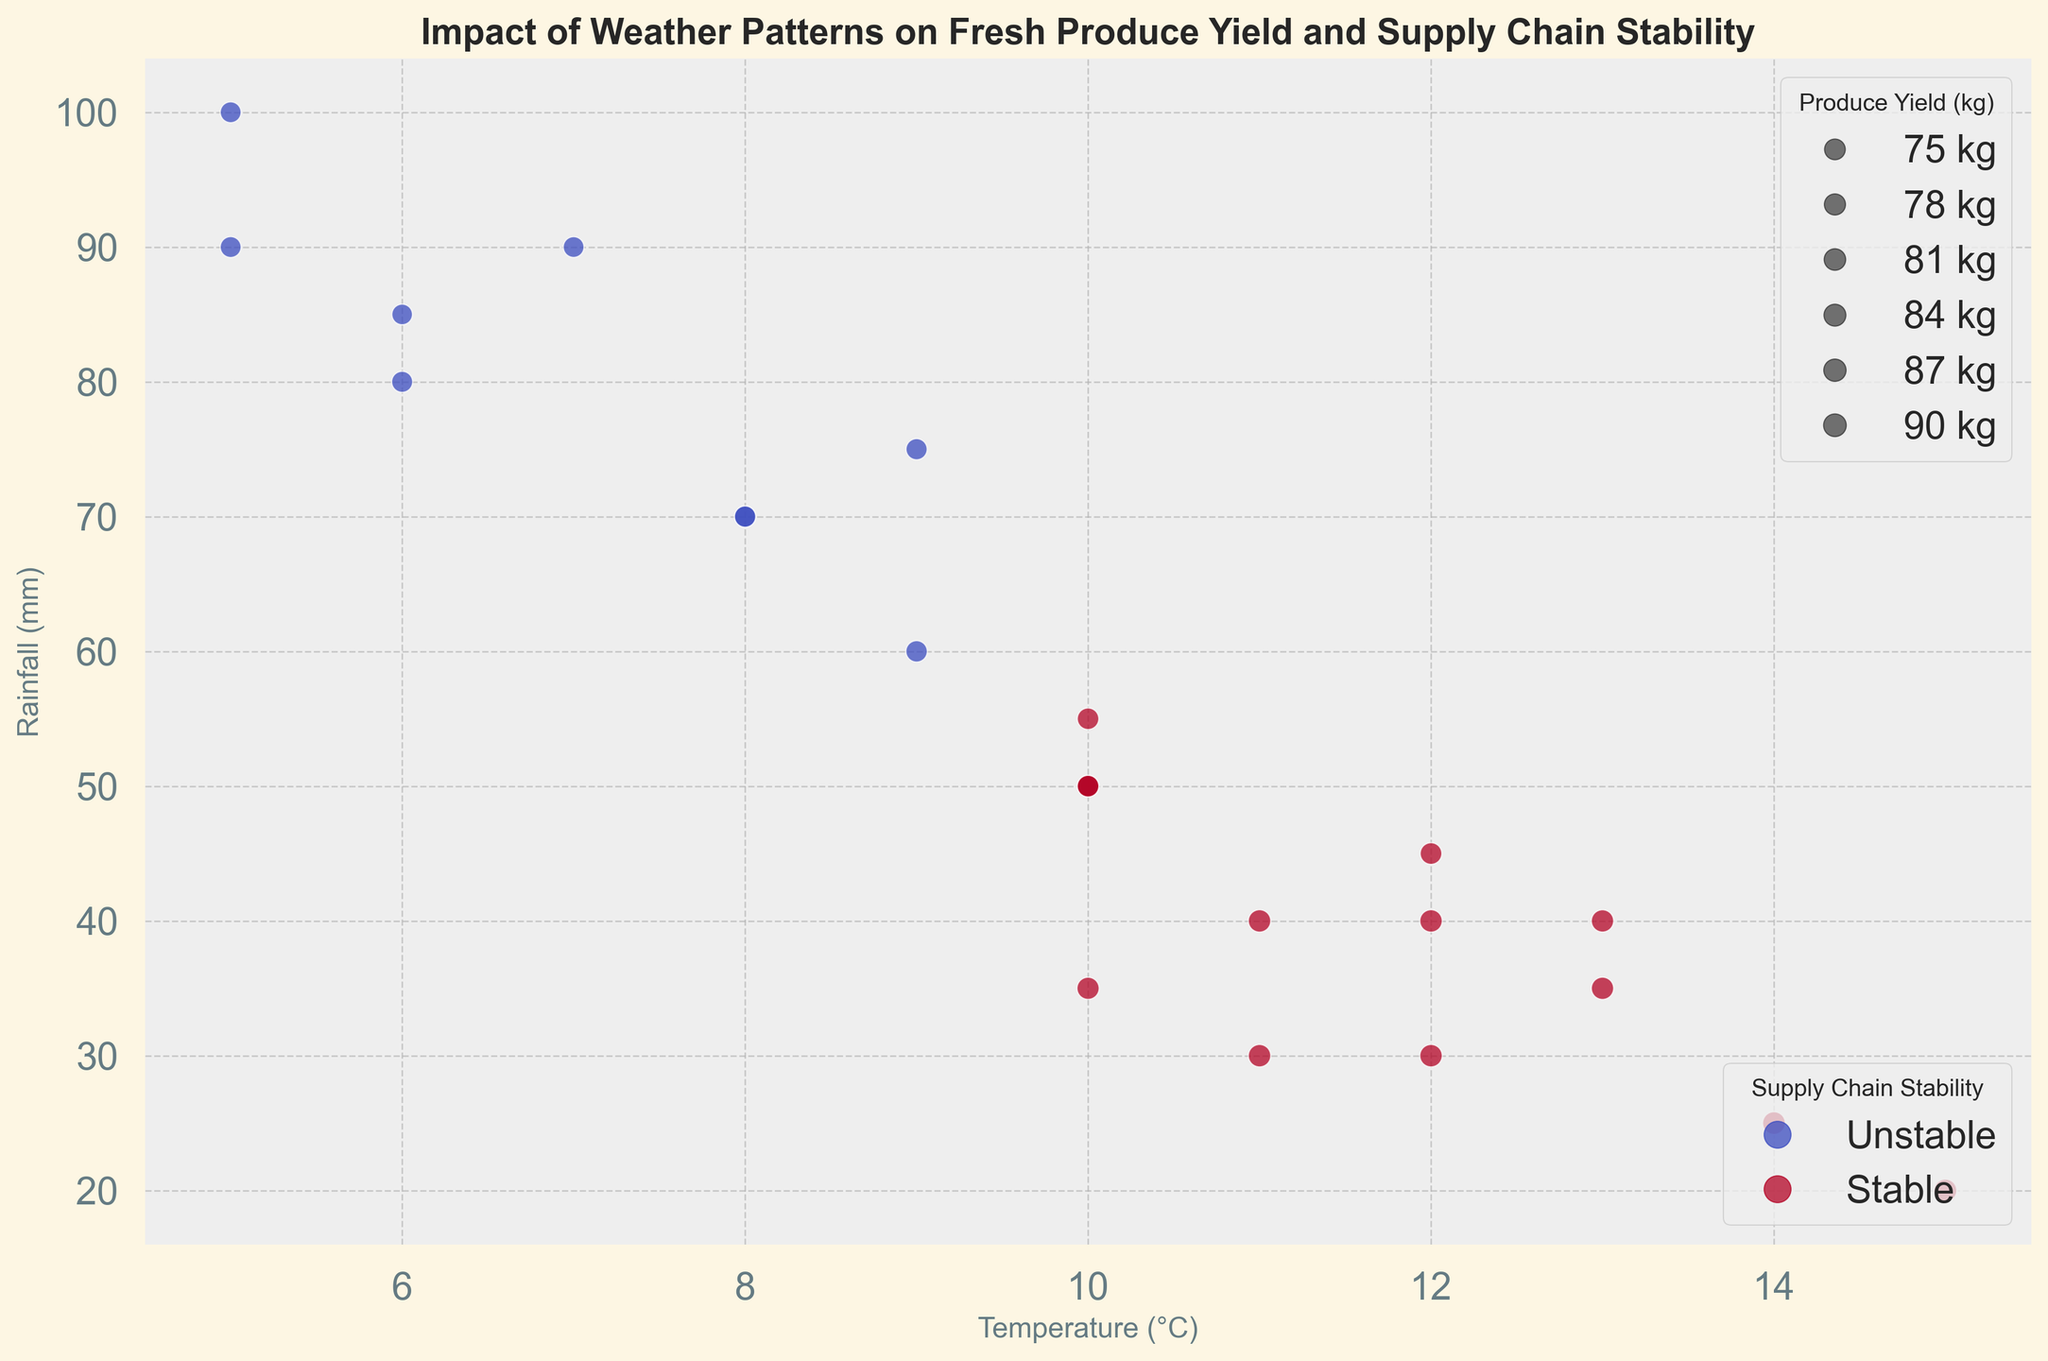What's the highest Produce Yield (kg) observed at a stable Supply Chain Stability? To find the highest Produce Yield at a stable Supply Chain, we look for the largest circle size among those colored indicating stability (which is likely a warmer color like red). The largest circle size in red happens to be 920 kg.
Answer: 920 kg What relationship do you observe between Temperature (°C) and Produce Yield (kg) for stable supply chains? By examining points with stable supply chain colors, we notice that as the temperature increases, larger yields (larger circles) tend to occur generally in mid-range temperatures from 10°C to 15°C. These are often larger than points with an unstable supply.
Answer: Mid-range temperatures show higher yields Which scenario shows a temperature of 8°C and features a stable supply chain? Identify the point at Temperature 8°C and check if it is colored to represent stability. An 8°C point with a warmer (likely red) color, corresponding to stable supply chains, occurs only when Rainfall is 70 mm.
Answer: Rainfall 70 mm Compare the Produce Yields (kg) at 15°C for both supply chain stability scenarios. At 15°C, check the circle sizes for different stability colors. Unstable points do not occur, thus we only see stable data series, one with Produce Yield at 850 kg and another at 910 kg.
Answer: 910 kg (Stable) What relationship can you observe about Rainfall (mm) and Supply Chain Stability? Examine the plot to note the colors associated with each rainfall level. Generally, stable supply chains tend to cluster below 60 mm of rainfall, while higher rainfall levels (over 70 mm) coincide with unstable supply chains.
Answer: Low Rainfall (< 60 mm) is more stable What is the average Produce Yield (kg) for unstable periods? Calculate the average of Produce Yield sizes for unstable data points: 790, 760, 800, 770, 750, 780, 740, 790, and 760. The sum of these values is 7240 kg, and dividing by 9 gives the average.
Answer: 804.4 kg Compare the stability levels at temperatures of both 5°C and 6°C. Look at the points for 5°C and 6°C and compare their colors. Both temperatures show a tendency towards instability (cooler colors), with Rainfall data showing both 100 mm and 80 mm correspondingly, indicating wet conditions.
Answer: Both unstable What pattern can you observe about Sunlight (hours) and Produce Yield (kg)? Larger circles (higher Produce Yields) often align with larger values of Sunlight hours. For instance, Sunlight hours of 8 or 9 coincide with higher yields.
Answer: More Sunlight yields more Produce Is there an optimal combination of Temperature (°C) and Rainfall (mm) leading to the highest Produce Yield? Check for the largest circle among the scatter plot. Here, 920 kg at 14°C with 25 mm Rainfall represents the optimal combination.
Answer: 14°C and 25 mm 